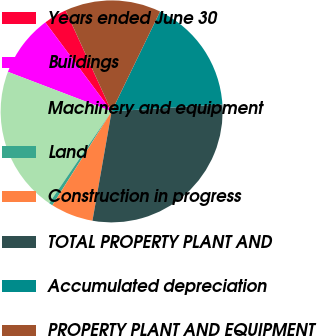Convert chart to OTSL. <chart><loc_0><loc_0><loc_500><loc_500><pie_chart><fcel>Years ended June 30<fcel>Buildings<fcel>Machinery and equipment<fcel>Land<fcel>Construction in progress<fcel>TOTAL PROPERTY PLANT AND<fcel>Accumulated depreciation<fcel>PROPERTY PLANT AND EQUIPMENT<nl><fcel>3.38%<fcel>9.02%<fcel>21.29%<fcel>0.55%<fcel>6.2%<fcel>28.77%<fcel>16.81%<fcel>13.99%<nl></chart> 